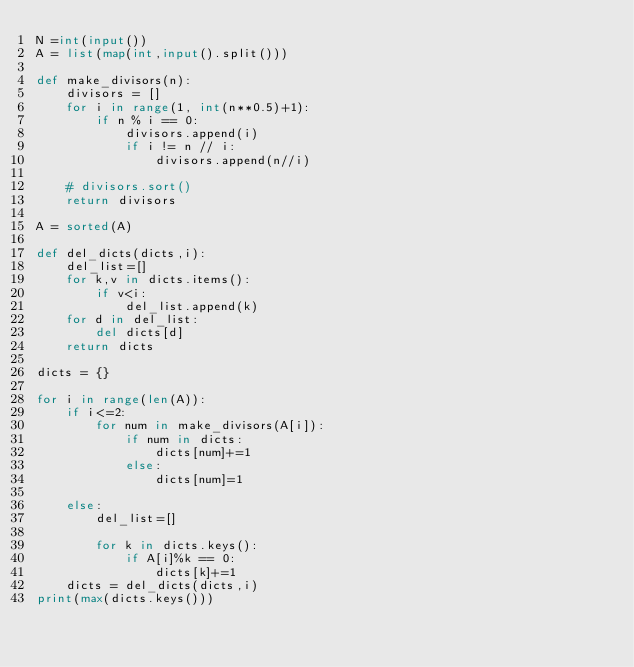<code> <loc_0><loc_0><loc_500><loc_500><_Python_>N =int(input())
A = list(map(int,input().split()))

def make_divisors(n):
    divisors = []
    for i in range(1, int(n**0.5)+1):
        if n % i == 0:
            divisors.append(i)
            if i != n // i:
                divisors.append(n//i)

    # divisors.sort()
    return divisors

A = sorted(A)

def del_dicts(dicts,i):
    del_list=[]
    for k,v in dicts.items():
        if v<i:
            del_list.append(k)
    for d in del_list:
        del dicts[d]
    return dicts

dicts = {}

for i in range(len(A)):
    if i<=2:
        for num in make_divisors(A[i]):
            if num in dicts:
                dicts[num]+=1
            else:
                dicts[num]=1
    
    else:
        del_list=[]
        
        for k in dicts.keys():
            if A[i]%k == 0:
                dicts[k]+=1
    dicts = del_dicts(dicts,i)
print(max(dicts.keys()))</code> 